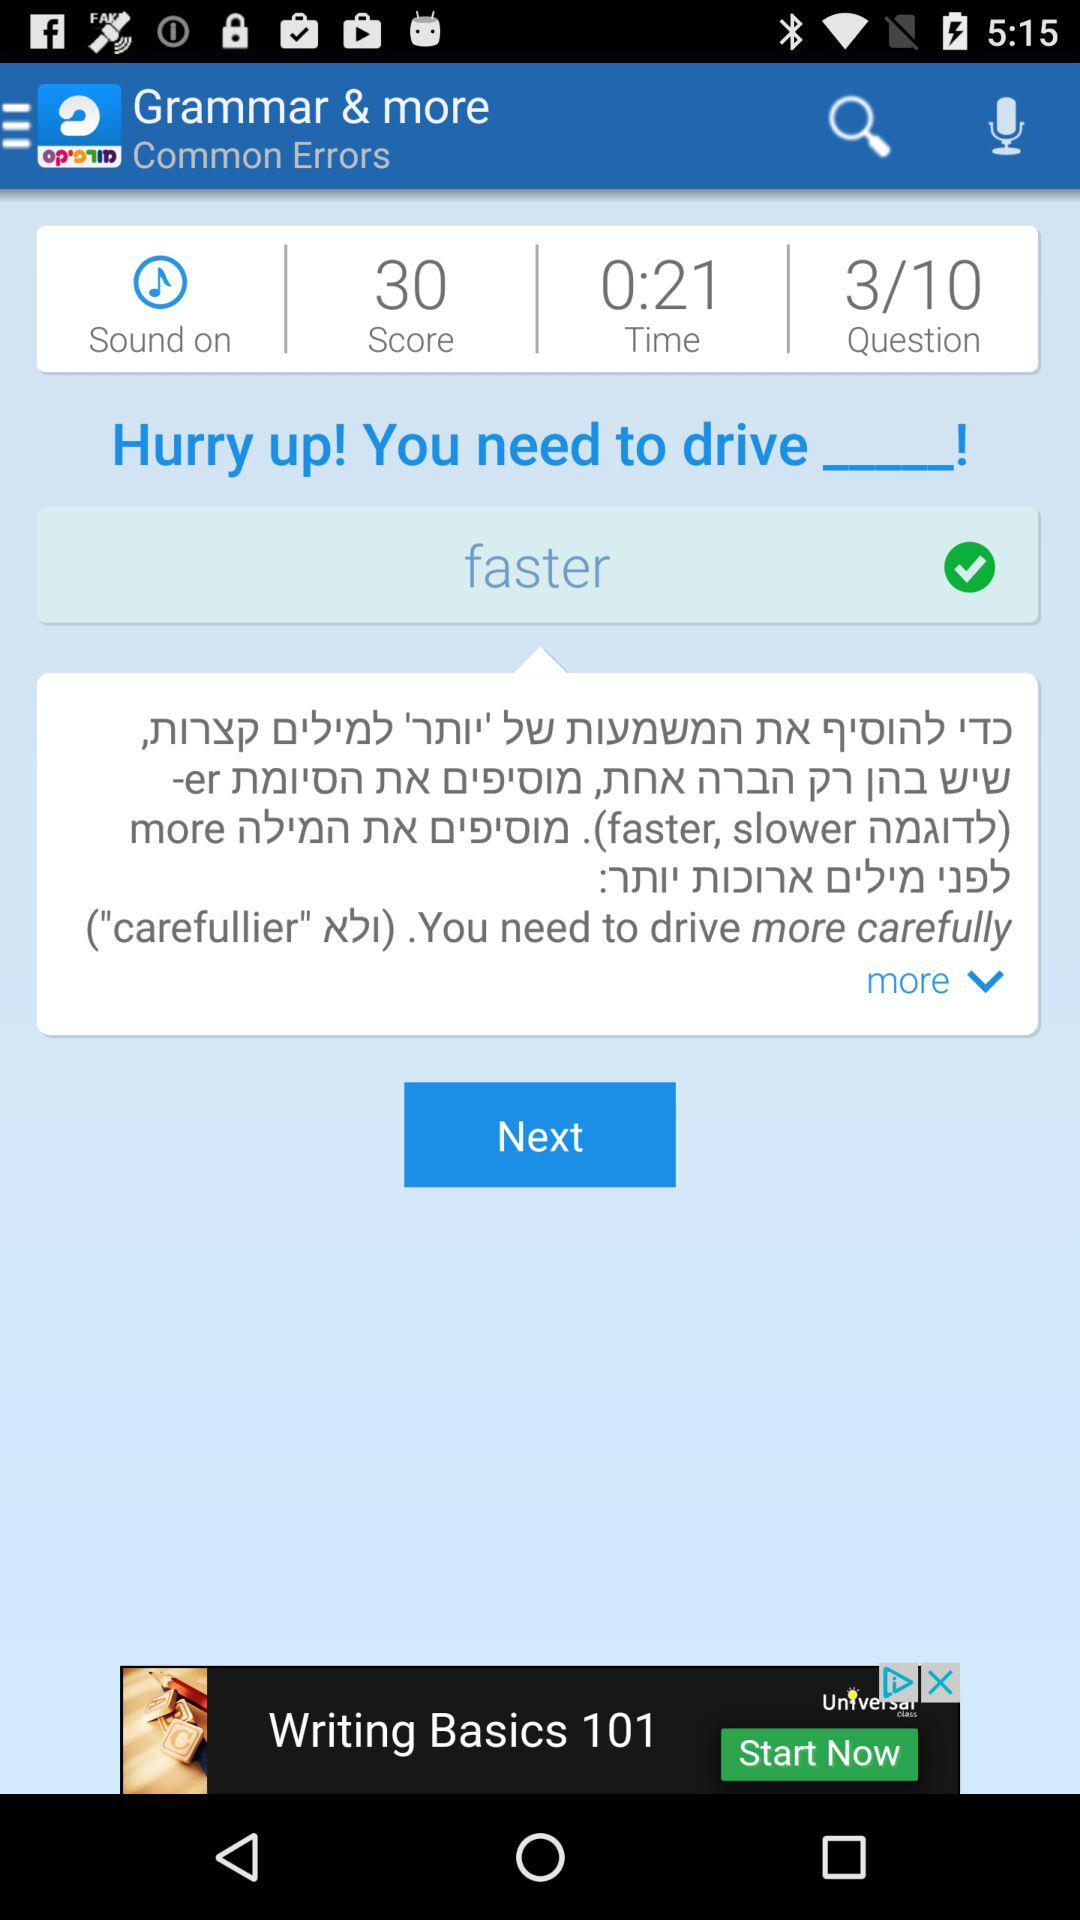How many questions were answered out of ten? The number of questions answered out of ten was 3. 